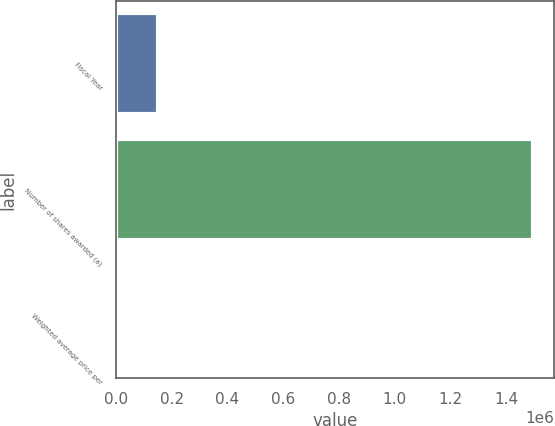<chart> <loc_0><loc_0><loc_500><loc_500><bar_chart><fcel>Fiscal Year<fcel>Number of shares awarded (a)<fcel>Weighted average price per<nl><fcel>149790<fcel>1.49748e+06<fcel>46.73<nl></chart> 